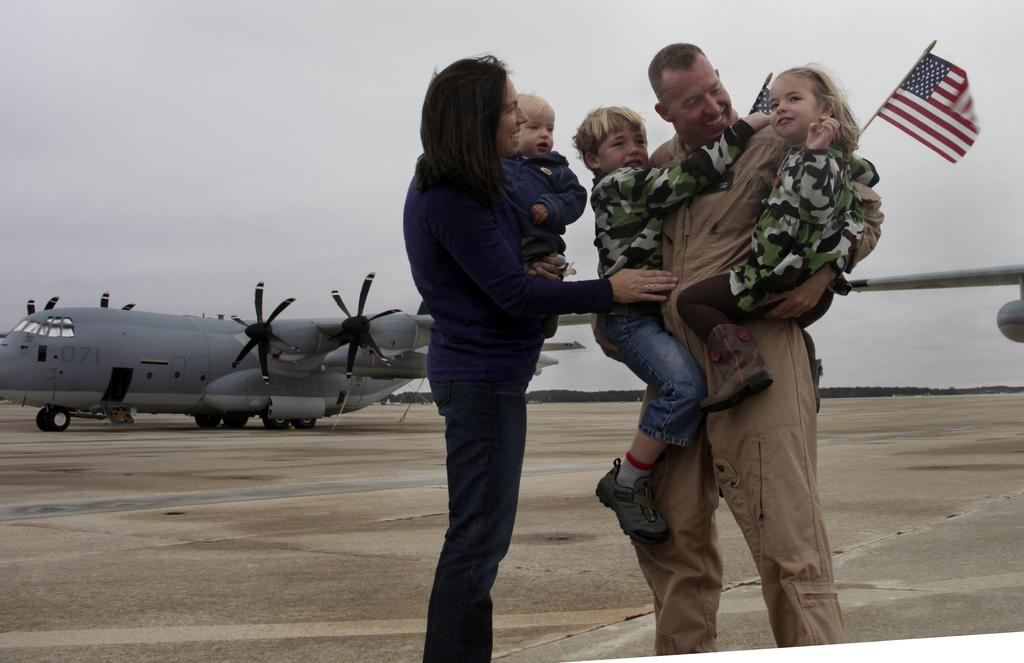How many people are in the image? There are two persons in the image. What are the persons doing in the image? The persons are holding babies. What is the facial expression of the persons? The persons are smiling. What can be seen in the background of the image? There is a flight, a flag, and the sky visible in the background. What type of club is the governor using in the image? There is no governor or club present in the image. What type of office is visible in the background of the image? There is no office visible in the background of the image. 